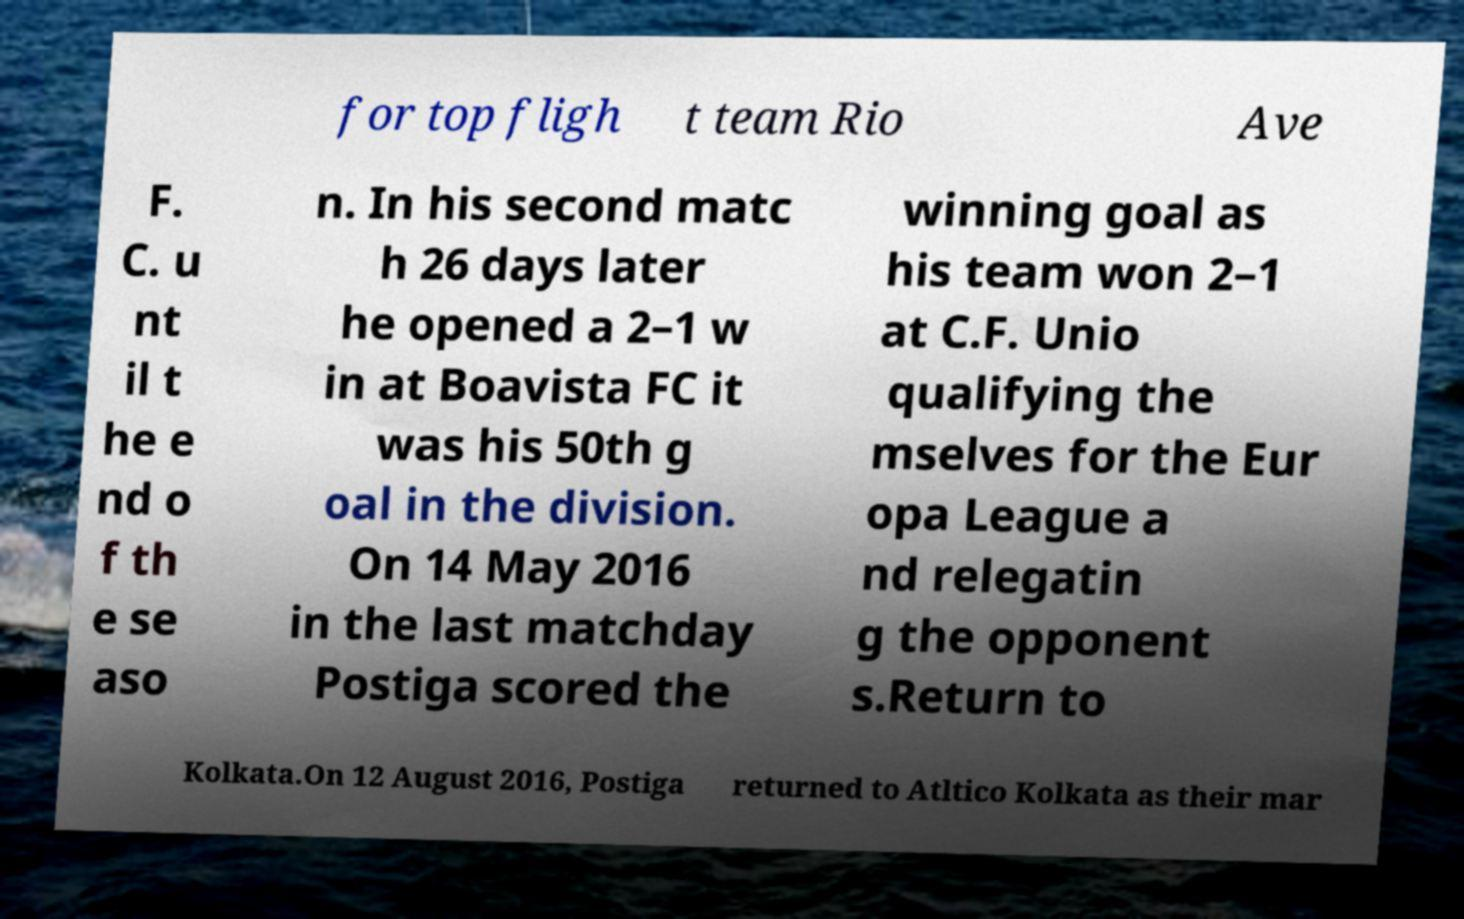Can you read and provide the text displayed in the image?This photo seems to have some interesting text. Can you extract and type it out for me? for top fligh t team Rio Ave F. C. u nt il t he e nd o f th e se aso n. In his second matc h 26 days later he opened a 2–1 w in at Boavista FC it was his 50th g oal in the division. On 14 May 2016 in the last matchday Postiga scored the winning goal as his team won 2–1 at C.F. Unio qualifying the mselves for the Eur opa League a nd relegatin g the opponent s.Return to Kolkata.On 12 August 2016, Postiga returned to Atltico Kolkata as their mar 